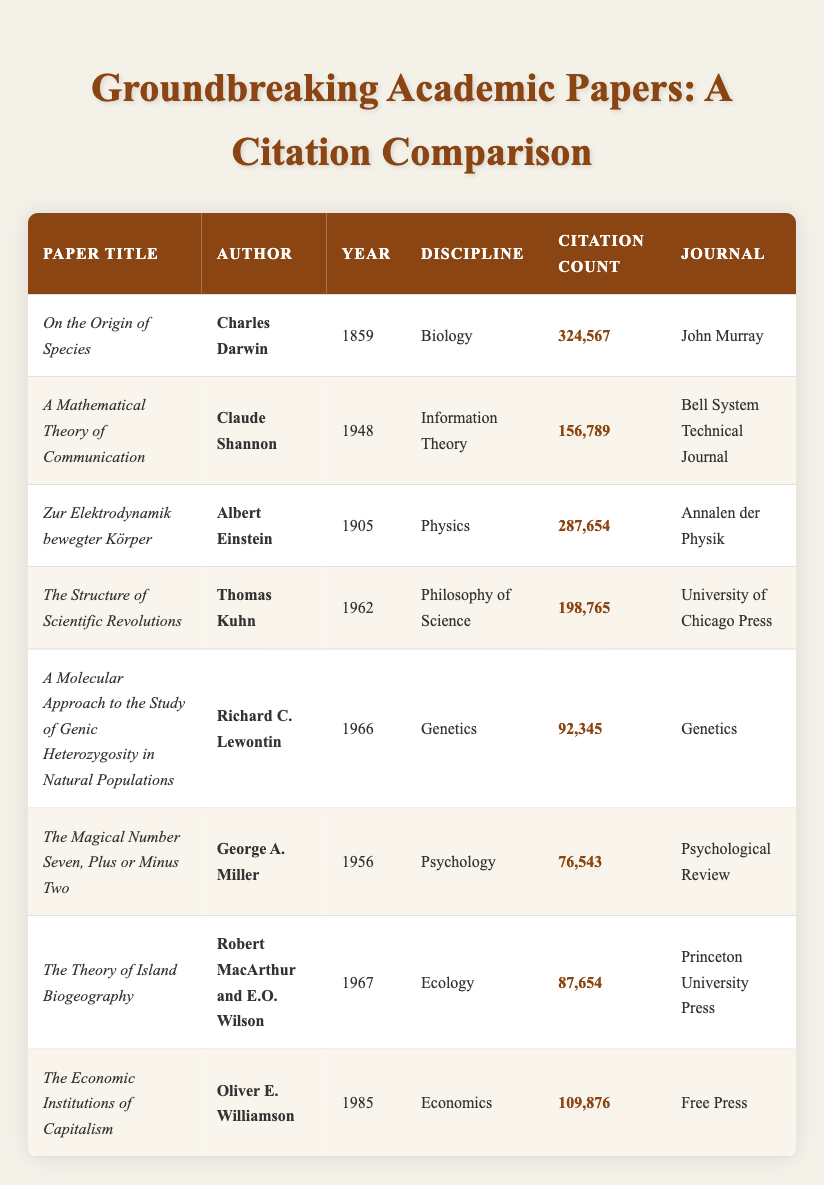What is the citation count of "On the Origin of Species"? Referring to the table, the row for "On the Origin of Species" indicates that its citation count is 324,567.
Answer: 324,567 Who is the author of the paper titled "The Structure of Scientific Revolutions"? By examining the row for "The Structure of Scientific Revolutions," we can see that it is authored by Thomas Kuhn.
Answer: Thomas Kuhn Which discipline has the highest citation count among the papers listed? The highest citation count is 324,567 for the paper "On the Origin of Species," which falls under Biology. Therefore, Biology has the highest citation count.
Answer: Biology What is the average citation count of the papers in the table? To find the average citation count, we first sum the citation counts: 324567 + 156789 + 287654 + 198765 + 92345 + 76543 + 87654 + 109876 = 1,100,088. Then, we divide by the total number of papers (8): 1,100,088 / 8 = 137,511.
Answer: 137,511 Was "The Economic Institutions of Capitalism" published before 1990? Checking the publication year for "The Economic Institutions of Capitalism," it was published in 1985, which is indeed before 1990. Therefore, the statement is true.
Answer: Yes How many papers in the table have a citation count greater than 100,000? By examining the citation counts: "On the Origin of Species" (324567), "Zur Elektrodynamik bewegter Körper" (287654), "The Structure of Scientific Revolutions" (198765), and "The Economic Institutions of Capitalism" (109876) are the only four papers with citation counts exceeding 100,000, resulting in a total of four papers.
Answer: 4 Is there any paper published in the 1960s that has more than 80,000 citations? Looking through the papers from the 1960s, "The Structure of Scientific Revolutions" (198765) and "The Theory of Island Biogeography" (87654) fit this criterion. "The Structure of Scientific Revolutions" has more than 80,000 citations, so the answer to the question is yes.
Answer: Yes Which author has the lowest citation count for their paper in this table? Amongst the papers, Richard C. Lewontin’s "A Molecular Approach to the Study of Genic Heterozygosity in Natural Populations" has the lowest citation count of 92,345, making him the author with the least citations listed.
Answer: Richard C. Lewontin 